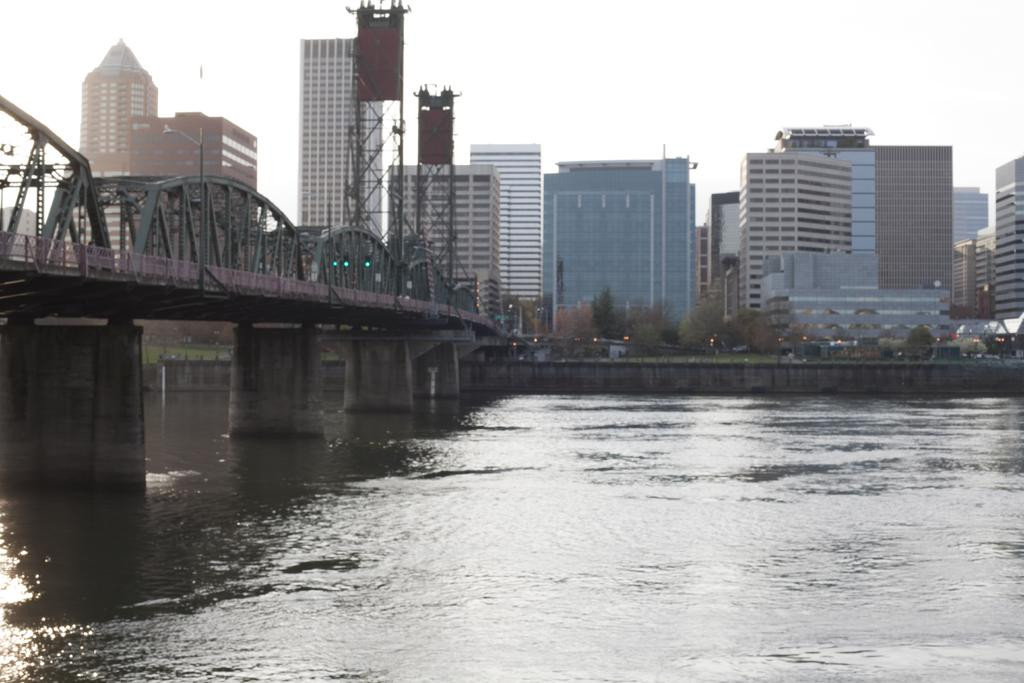What is the main feature of the image? The main feature of the image is water. What structure can be seen crossing over the water? There is a bridge in the image. What else can be seen in the image besides water and the bridge? There are buildings and trees in the image. What is visible in the background of the image? The sky is visible in the background of the image. Reasoning: Let' Let's think step by step in order to produce the conversation. We start by identifying the main subject of the image, which is the water. Then, we describe the bridge that crosses over the water, as well as the buildings and trees that are also present. Finally, we mention the sky that is visible in the background of the image. Absurd Question/Answer: What type of letter is being delivered by the group of lips in the image? There is no group of lips or letter present in the image. 